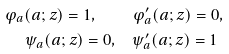Convert formula to latex. <formula><loc_0><loc_0><loc_500><loc_500>\varphi _ { a } ( a ; z ) = 1 , \quad & \varphi ^ { \prime } _ { a } ( a ; z ) = 0 , \\ \psi _ { a } ( a ; z ) = 0 , \quad & \psi _ { a } ^ { \prime } ( a ; z ) = 1</formula> 